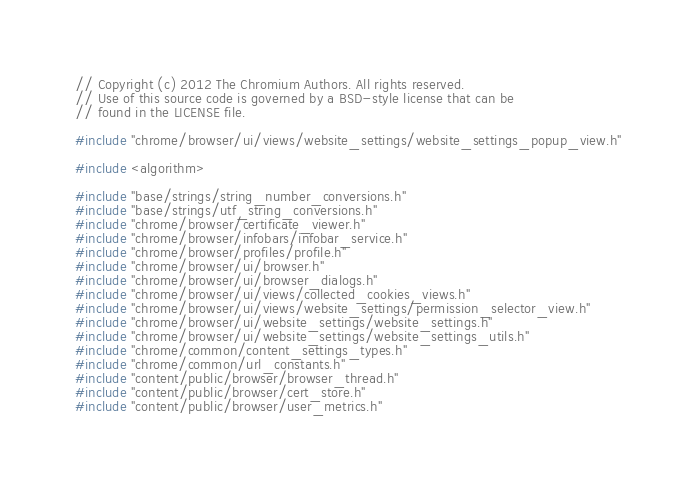Convert code to text. <code><loc_0><loc_0><loc_500><loc_500><_C++_>// Copyright (c) 2012 The Chromium Authors. All rights reserved.
// Use of this source code is governed by a BSD-style license that can be
// found in the LICENSE file.

#include "chrome/browser/ui/views/website_settings/website_settings_popup_view.h"

#include <algorithm>

#include "base/strings/string_number_conversions.h"
#include "base/strings/utf_string_conversions.h"
#include "chrome/browser/certificate_viewer.h"
#include "chrome/browser/infobars/infobar_service.h"
#include "chrome/browser/profiles/profile.h"
#include "chrome/browser/ui/browser.h"
#include "chrome/browser/ui/browser_dialogs.h"
#include "chrome/browser/ui/views/collected_cookies_views.h"
#include "chrome/browser/ui/views/website_settings/permission_selector_view.h"
#include "chrome/browser/ui/website_settings/website_settings.h"
#include "chrome/browser/ui/website_settings/website_settings_utils.h"
#include "chrome/common/content_settings_types.h"
#include "chrome/common/url_constants.h"
#include "content/public/browser/browser_thread.h"
#include "content/public/browser/cert_store.h"
#include "content/public/browser/user_metrics.h"</code> 